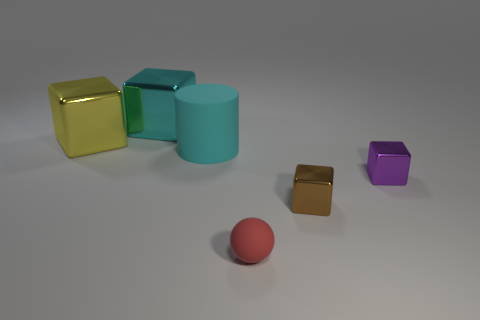Add 3 balls. How many objects exist? 9 Subtract 0 gray blocks. How many objects are left? 6 Subtract all spheres. How many objects are left? 5 Subtract 1 spheres. How many spheres are left? 0 Subtract all cyan cubes. Subtract all cyan cylinders. How many cubes are left? 3 Subtract all brown blocks. How many gray balls are left? 0 Subtract all gray rubber spheres. Subtract all yellow blocks. How many objects are left? 5 Add 4 tiny brown things. How many tiny brown things are left? 5 Add 4 big yellow metal things. How many big yellow metal things exist? 5 Subtract all yellow cubes. How many cubes are left? 3 